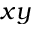<formula> <loc_0><loc_0><loc_500><loc_500>x y</formula> 